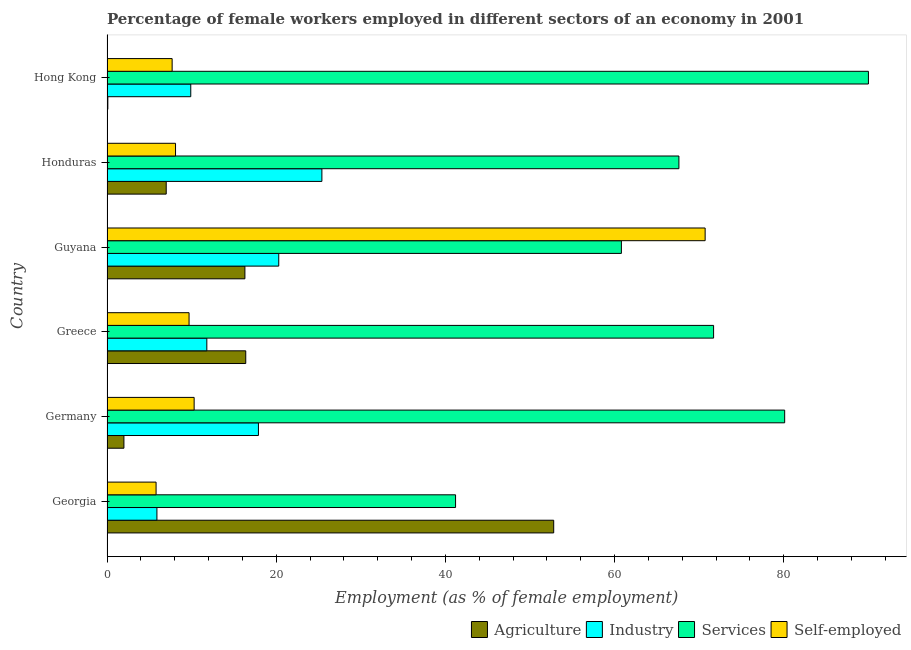How many different coloured bars are there?
Provide a succinct answer. 4. How many groups of bars are there?
Your answer should be very brief. 6. Are the number of bars on each tick of the Y-axis equal?
Keep it short and to the point. Yes. How many bars are there on the 5th tick from the bottom?
Make the answer very short. 4. What is the label of the 3rd group of bars from the top?
Your answer should be compact. Guyana. What is the percentage of female workers in services in Georgia?
Provide a short and direct response. 41.2. Across all countries, what is the maximum percentage of female workers in services?
Make the answer very short. 90. Across all countries, what is the minimum percentage of female workers in agriculture?
Your answer should be very brief. 0.1. In which country was the percentage of female workers in industry maximum?
Keep it short and to the point. Honduras. In which country was the percentage of female workers in industry minimum?
Offer a terse response. Georgia. What is the total percentage of female workers in services in the graph?
Ensure brevity in your answer.  411.4. What is the difference between the percentage of female workers in agriculture in Honduras and the percentage of female workers in services in Georgia?
Ensure brevity in your answer.  -34.2. What is the average percentage of female workers in services per country?
Ensure brevity in your answer.  68.57. In how many countries, is the percentage of self employed female workers greater than 44 %?
Make the answer very short. 1. What is the ratio of the percentage of female workers in industry in Georgia to that in Greece?
Offer a terse response. 0.5. Is the percentage of female workers in industry in Georgia less than that in Germany?
Offer a terse response. Yes. Is the difference between the percentage of female workers in services in Greece and Guyana greater than the difference between the percentage of female workers in industry in Greece and Guyana?
Give a very brief answer. Yes. What is the difference between the highest and the second highest percentage of female workers in agriculture?
Keep it short and to the point. 36.4. What is the difference between the highest and the lowest percentage of female workers in services?
Keep it short and to the point. 48.8. What does the 4th bar from the top in Germany represents?
Offer a very short reply. Agriculture. What does the 1st bar from the bottom in Guyana represents?
Give a very brief answer. Agriculture. Is it the case that in every country, the sum of the percentage of female workers in agriculture and percentage of female workers in industry is greater than the percentage of female workers in services?
Offer a very short reply. No. How many bars are there?
Keep it short and to the point. 24. What is the difference between two consecutive major ticks on the X-axis?
Give a very brief answer. 20. Does the graph contain grids?
Your response must be concise. No. Where does the legend appear in the graph?
Your response must be concise. Bottom right. How many legend labels are there?
Ensure brevity in your answer.  4. What is the title of the graph?
Offer a terse response. Percentage of female workers employed in different sectors of an economy in 2001. Does "Payroll services" appear as one of the legend labels in the graph?
Keep it short and to the point. No. What is the label or title of the X-axis?
Make the answer very short. Employment (as % of female employment). What is the Employment (as % of female employment) in Agriculture in Georgia?
Offer a terse response. 52.8. What is the Employment (as % of female employment) in Industry in Georgia?
Ensure brevity in your answer.  5.9. What is the Employment (as % of female employment) of Services in Georgia?
Keep it short and to the point. 41.2. What is the Employment (as % of female employment) in Self-employed in Georgia?
Provide a succinct answer. 5.8. What is the Employment (as % of female employment) of Industry in Germany?
Your answer should be very brief. 17.9. What is the Employment (as % of female employment) of Services in Germany?
Your answer should be compact. 80.1. What is the Employment (as % of female employment) of Self-employed in Germany?
Your answer should be compact. 10.3. What is the Employment (as % of female employment) in Agriculture in Greece?
Offer a very short reply. 16.4. What is the Employment (as % of female employment) in Industry in Greece?
Provide a succinct answer. 11.8. What is the Employment (as % of female employment) in Services in Greece?
Provide a succinct answer. 71.7. What is the Employment (as % of female employment) of Self-employed in Greece?
Offer a very short reply. 9.7. What is the Employment (as % of female employment) of Agriculture in Guyana?
Make the answer very short. 16.3. What is the Employment (as % of female employment) in Industry in Guyana?
Your answer should be compact. 20.3. What is the Employment (as % of female employment) of Services in Guyana?
Offer a very short reply. 60.8. What is the Employment (as % of female employment) in Self-employed in Guyana?
Your response must be concise. 70.7. What is the Employment (as % of female employment) of Industry in Honduras?
Make the answer very short. 25.4. What is the Employment (as % of female employment) of Services in Honduras?
Keep it short and to the point. 67.6. What is the Employment (as % of female employment) of Self-employed in Honduras?
Provide a short and direct response. 8.1. What is the Employment (as % of female employment) of Agriculture in Hong Kong?
Provide a succinct answer. 0.1. What is the Employment (as % of female employment) in Industry in Hong Kong?
Offer a very short reply. 9.9. What is the Employment (as % of female employment) in Services in Hong Kong?
Offer a very short reply. 90. What is the Employment (as % of female employment) of Self-employed in Hong Kong?
Keep it short and to the point. 7.7. Across all countries, what is the maximum Employment (as % of female employment) in Agriculture?
Provide a succinct answer. 52.8. Across all countries, what is the maximum Employment (as % of female employment) of Industry?
Ensure brevity in your answer.  25.4. Across all countries, what is the maximum Employment (as % of female employment) of Services?
Provide a short and direct response. 90. Across all countries, what is the maximum Employment (as % of female employment) of Self-employed?
Offer a terse response. 70.7. Across all countries, what is the minimum Employment (as % of female employment) in Agriculture?
Your response must be concise. 0.1. Across all countries, what is the minimum Employment (as % of female employment) in Industry?
Offer a terse response. 5.9. Across all countries, what is the minimum Employment (as % of female employment) of Services?
Offer a very short reply. 41.2. Across all countries, what is the minimum Employment (as % of female employment) of Self-employed?
Make the answer very short. 5.8. What is the total Employment (as % of female employment) in Agriculture in the graph?
Offer a very short reply. 94.6. What is the total Employment (as % of female employment) of Industry in the graph?
Your response must be concise. 91.2. What is the total Employment (as % of female employment) in Services in the graph?
Your answer should be compact. 411.4. What is the total Employment (as % of female employment) in Self-employed in the graph?
Keep it short and to the point. 112.3. What is the difference between the Employment (as % of female employment) of Agriculture in Georgia and that in Germany?
Your answer should be compact. 50.8. What is the difference between the Employment (as % of female employment) in Industry in Georgia and that in Germany?
Make the answer very short. -12. What is the difference between the Employment (as % of female employment) of Services in Georgia and that in Germany?
Offer a very short reply. -38.9. What is the difference between the Employment (as % of female employment) of Agriculture in Georgia and that in Greece?
Give a very brief answer. 36.4. What is the difference between the Employment (as % of female employment) in Services in Georgia and that in Greece?
Make the answer very short. -30.5. What is the difference between the Employment (as % of female employment) in Self-employed in Georgia and that in Greece?
Offer a very short reply. -3.9. What is the difference between the Employment (as % of female employment) of Agriculture in Georgia and that in Guyana?
Ensure brevity in your answer.  36.5. What is the difference between the Employment (as % of female employment) in Industry in Georgia and that in Guyana?
Make the answer very short. -14.4. What is the difference between the Employment (as % of female employment) in Services in Georgia and that in Guyana?
Your answer should be compact. -19.6. What is the difference between the Employment (as % of female employment) of Self-employed in Georgia and that in Guyana?
Your response must be concise. -64.9. What is the difference between the Employment (as % of female employment) of Agriculture in Georgia and that in Honduras?
Provide a succinct answer. 45.8. What is the difference between the Employment (as % of female employment) in Industry in Georgia and that in Honduras?
Your answer should be compact. -19.5. What is the difference between the Employment (as % of female employment) of Services in Georgia and that in Honduras?
Offer a very short reply. -26.4. What is the difference between the Employment (as % of female employment) of Agriculture in Georgia and that in Hong Kong?
Your answer should be very brief. 52.7. What is the difference between the Employment (as % of female employment) of Services in Georgia and that in Hong Kong?
Your response must be concise. -48.8. What is the difference between the Employment (as % of female employment) of Self-employed in Georgia and that in Hong Kong?
Keep it short and to the point. -1.9. What is the difference between the Employment (as % of female employment) of Agriculture in Germany and that in Greece?
Your response must be concise. -14.4. What is the difference between the Employment (as % of female employment) in Services in Germany and that in Greece?
Give a very brief answer. 8.4. What is the difference between the Employment (as % of female employment) in Self-employed in Germany and that in Greece?
Keep it short and to the point. 0.6. What is the difference between the Employment (as % of female employment) of Agriculture in Germany and that in Guyana?
Offer a very short reply. -14.3. What is the difference between the Employment (as % of female employment) of Services in Germany and that in Guyana?
Your answer should be very brief. 19.3. What is the difference between the Employment (as % of female employment) in Self-employed in Germany and that in Guyana?
Ensure brevity in your answer.  -60.4. What is the difference between the Employment (as % of female employment) of Industry in Germany and that in Honduras?
Your answer should be very brief. -7.5. What is the difference between the Employment (as % of female employment) of Services in Germany and that in Honduras?
Offer a very short reply. 12.5. What is the difference between the Employment (as % of female employment) in Agriculture in Germany and that in Hong Kong?
Make the answer very short. 1.9. What is the difference between the Employment (as % of female employment) of Industry in Germany and that in Hong Kong?
Give a very brief answer. 8. What is the difference between the Employment (as % of female employment) of Services in Germany and that in Hong Kong?
Provide a short and direct response. -9.9. What is the difference between the Employment (as % of female employment) in Self-employed in Greece and that in Guyana?
Your answer should be compact. -61. What is the difference between the Employment (as % of female employment) in Services in Greece and that in Honduras?
Your response must be concise. 4.1. What is the difference between the Employment (as % of female employment) of Self-employed in Greece and that in Honduras?
Offer a very short reply. 1.6. What is the difference between the Employment (as % of female employment) in Agriculture in Greece and that in Hong Kong?
Ensure brevity in your answer.  16.3. What is the difference between the Employment (as % of female employment) in Industry in Greece and that in Hong Kong?
Your response must be concise. 1.9. What is the difference between the Employment (as % of female employment) of Services in Greece and that in Hong Kong?
Your answer should be very brief. -18.3. What is the difference between the Employment (as % of female employment) of Self-employed in Greece and that in Hong Kong?
Ensure brevity in your answer.  2. What is the difference between the Employment (as % of female employment) in Agriculture in Guyana and that in Honduras?
Ensure brevity in your answer.  9.3. What is the difference between the Employment (as % of female employment) of Industry in Guyana and that in Honduras?
Keep it short and to the point. -5.1. What is the difference between the Employment (as % of female employment) of Services in Guyana and that in Honduras?
Provide a succinct answer. -6.8. What is the difference between the Employment (as % of female employment) in Self-employed in Guyana and that in Honduras?
Ensure brevity in your answer.  62.6. What is the difference between the Employment (as % of female employment) of Services in Guyana and that in Hong Kong?
Offer a terse response. -29.2. What is the difference between the Employment (as % of female employment) in Self-employed in Guyana and that in Hong Kong?
Keep it short and to the point. 63. What is the difference between the Employment (as % of female employment) in Services in Honduras and that in Hong Kong?
Provide a succinct answer. -22.4. What is the difference between the Employment (as % of female employment) of Agriculture in Georgia and the Employment (as % of female employment) of Industry in Germany?
Provide a short and direct response. 34.9. What is the difference between the Employment (as % of female employment) of Agriculture in Georgia and the Employment (as % of female employment) of Services in Germany?
Ensure brevity in your answer.  -27.3. What is the difference between the Employment (as % of female employment) in Agriculture in Georgia and the Employment (as % of female employment) in Self-employed in Germany?
Make the answer very short. 42.5. What is the difference between the Employment (as % of female employment) of Industry in Georgia and the Employment (as % of female employment) of Services in Germany?
Your answer should be very brief. -74.2. What is the difference between the Employment (as % of female employment) in Services in Georgia and the Employment (as % of female employment) in Self-employed in Germany?
Offer a terse response. 30.9. What is the difference between the Employment (as % of female employment) of Agriculture in Georgia and the Employment (as % of female employment) of Services in Greece?
Ensure brevity in your answer.  -18.9. What is the difference between the Employment (as % of female employment) of Agriculture in Georgia and the Employment (as % of female employment) of Self-employed in Greece?
Offer a terse response. 43.1. What is the difference between the Employment (as % of female employment) in Industry in Georgia and the Employment (as % of female employment) in Services in Greece?
Offer a terse response. -65.8. What is the difference between the Employment (as % of female employment) in Industry in Georgia and the Employment (as % of female employment) in Self-employed in Greece?
Make the answer very short. -3.8. What is the difference between the Employment (as % of female employment) of Services in Georgia and the Employment (as % of female employment) of Self-employed in Greece?
Your answer should be very brief. 31.5. What is the difference between the Employment (as % of female employment) of Agriculture in Georgia and the Employment (as % of female employment) of Industry in Guyana?
Make the answer very short. 32.5. What is the difference between the Employment (as % of female employment) in Agriculture in Georgia and the Employment (as % of female employment) in Services in Guyana?
Ensure brevity in your answer.  -8. What is the difference between the Employment (as % of female employment) of Agriculture in Georgia and the Employment (as % of female employment) of Self-employed in Guyana?
Your response must be concise. -17.9. What is the difference between the Employment (as % of female employment) of Industry in Georgia and the Employment (as % of female employment) of Services in Guyana?
Provide a short and direct response. -54.9. What is the difference between the Employment (as % of female employment) of Industry in Georgia and the Employment (as % of female employment) of Self-employed in Guyana?
Provide a succinct answer. -64.8. What is the difference between the Employment (as % of female employment) in Services in Georgia and the Employment (as % of female employment) in Self-employed in Guyana?
Offer a very short reply. -29.5. What is the difference between the Employment (as % of female employment) in Agriculture in Georgia and the Employment (as % of female employment) in Industry in Honduras?
Keep it short and to the point. 27.4. What is the difference between the Employment (as % of female employment) in Agriculture in Georgia and the Employment (as % of female employment) in Services in Honduras?
Provide a short and direct response. -14.8. What is the difference between the Employment (as % of female employment) of Agriculture in Georgia and the Employment (as % of female employment) of Self-employed in Honduras?
Make the answer very short. 44.7. What is the difference between the Employment (as % of female employment) in Industry in Georgia and the Employment (as % of female employment) in Services in Honduras?
Offer a terse response. -61.7. What is the difference between the Employment (as % of female employment) in Services in Georgia and the Employment (as % of female employment) in Self-employed in Honduras?
Offer a terse response. 33.1. What is the difference between the Employment (as % of female employment) in Agriculture in Georgia and the Employment (as % of female employment) in Industry in Hong Kong?
Keep it short and to the point. 42.9. What is the difference between the Employment (as % of female employment) in Agriculture in Georgia and the Employment (as % of female employment) in Services in Hong Kong?
Keep it short and to the point. -37.2. What is the difference between the Employment (as % of female employment) of Agriculture in Georgia and the Employment (as % of female employment) of Self-employed in Hong Kong?
Keep it short and to the point. 45.1. What is the difference between the Employment (as % of female employment) in Industry in Georgia and the Employment (as % of female employment) in Services in Hong Kong?
Offer a terse response. -84.1. What is the difference between the Employment (as % of female employment) of Services in Georgia and the Employment (as % of female employment) of Self-employed in Hong Kong?
Offer a terse response. 33.5. What is the difference between the Employment (as % of female employment) in Agriculture in Germany and the Employment (as % of female employment) in Services in Greece?
Your response must be concise. -69.7. What is the difference between the Employment (as % of female employment) in Agriculture in Germany and the Employment (as % of female employment) in Self-employed in Greece?
Make the answer very short. -7.7. What is the difference between the Employment (as % of female employment) in Industry in Germany and the Employment (as % of female employment) in Services in Greece?
Your response must be concise. -53.8. What is the difference between the Employment (as % of female employment) of Industry in Germany and the Employment (as % of female employment) of Self-employed in Greece?
Ensure brevity in your answer.  8.2. What is the difference between the Employment (as % of female employment) of Services in Germany and the Employment (as % of female employment) of Self-employed in Greece?
Provide a succinct answer. 70.4. What is the difference between the Employment (as % of female employment) in Agriculture in Germany and the Employment (as % of female employment) in Industry in Guyana?
Offer a very short reply. -18.3. What is the difference between the Employment (as % of female employment) of Agriculture in Germany and the Employment (as % of female employment) of Services in Guyana?
Ensure brevity in your answer.  -58.8. What is the difference between the Employment (as % of female employment) of Agriculture in Germany and the Employment (as % of female employment) of Self-employed in Guyana?
Keep it short and to the point. -68.7. What is the difference between the Employment (as % of female employment) in Industry in Germany and the Employment (as % of female employment) in Services in Guyana?
Ensure brevity in your answer.  -42.9. What is the difference between the Employment (as % of female employment) in Industry in Germany and the Employment (as % of female employment) in Self-employed in Guyana?
Make the answer very short. -52.8. What is the difference between the Employment (as % of female employment) in Services in Germany and the Employment (as % of female employment) in Self-employed in Guyana?
Make the answer very short. 9.4. What is the difference between the Employment (as % of female employment) of Agriculture in Germany and the Employment (as % of female employment) of Industry in Honduras?
Your response must be concise. -23.4. What is the difference between the Employment (as % of female employment) in Agriculture in Germany and the Employment (as % of female employment) in Services in Honduras?
Make the answer very short. -65.6. What is the difference between the Employment (as % of female employment) of Industry in Germany and the Employment (as % of female employment) of Services in Honduras?
Offer a very short reply. -49.7. What is the difference between the Employment (as % of female employment) of Industry in Germany and the Employment (as % of female employment) of Self-employed in Honduras?
Your answer should be very brief. 9.8. What is the difference between the Employment (as % of female employment) in Services in Germany and the Employment (as % of female employment) in Self-employed in Honduras?
Your answer should be compact. 72. What is the difference between the Employment (as % of female employment) of Agriculture in Germany and the Employment (as % of female employment) of Industry in Hong Kong?
Offer a terse response. -7.9. What is the difference between the Employment (as % of female employment) of Agriculture in Germany and the Employment (as % of female employment) of Services in Hong Kong?
Give a very brief answer. -88. What is the difference between the Employment (as % of female employment) of Agriculture in Germany and the Employment (as % of female employment) of Self-employed in Hong Kong?
Your answer should be compact. -5.7. What is the difference between the Employment (as % of female employment) in Industry in Germany and the Employment (as % of female employment) in Services in Hong Kong?
Offer a very short reply. -72.1. What is the difference between the Employment (as % of female employment) in Industry in Germany and the Employment (as % of female employment) in Self-employed in Hong Kong?
Keep it short and to the point. 10.2. What is the difference between the Employment (as % of female employment) in Services in Germany and the Employment (as % of female employment) in Self-employed in Hong Kong?
Provide a short and direct response. 72.4. What is the difference between the Employment (as % of female employment) in Agriculture in Greece and the Employment (as % of female employment) in Services in Guyana?
Your answer should be very brief. -44.4. What is the difference between the Employment (as % of female employment) of Agriculture in Greece and the Employment (as % of female employment) of Self-employed in Guyana?
Your answer should be very brief. -54.3. What is the difference between the Employment (as % of female employment) in Industry in Greece and the Employment (as % of female employment) in Services in Guyana?
Offer a terse response. -49. What is the difference between the Employment (as % of female employment) in Industry in Greece and the Employment (as % of female employment) in Self-employed in Guyana?
Make the answer very short. -58.9. What is the difference between the Employment (as % of female employment) in Agriculture in Greece and the Employment (as % of female employment) in Services in Honduras?
Offer a terse response. -51.2. What is the difference between the Employment (as % of female employment) in Agriculture in Greece and the Employment (as % of female employment) in Self-employed in Honduras?
Offer a very short reply. 8.3. What is the difference between the Employment (as % of female employment) in Industry in Greece and the Employment (as % of female employment) in Services in Honduras?
Your answer should be compact. -55.8. What is the difference between the Employment (as % of female employment) in Services in Greece and the Employment (as % of female employment) in Self-employed in Honduras?
Your answer should be compact. 63.6. What is the difference between the Employment (as % of female employment) in Agriculture in Greece and the Employment (as % of female employment) in Services in Hong Kong?
Keep it short and to the point. -73.6. What is the difference between the Employment (as % of female employment) of Industry in Greece and the Employment (as % of female employment) of Services in Hong Kong?
Offer a terse response. -78.2. What is the difference between the Employment (as % of female employment) in Agriculture in Guyana and the Employment (as % of female employment) in Services in Honduras?
Provide a succinct answer. -51.3. What is the difference between the Employment (as % of female employment) in Industry in Guyana and the Employment (as % of female employment) in Services in Honduras?
Give a very brief answer. -47.3. What is the difference between the Employment (as % of female employment) of Services in Guyana and the Employment (as % of female employment) of Self-employed in Honduras?
Make the answer very short. 52.7. What is the difference between the Employment (as % of female employment) in Agriculture in Guyana and the Employment (as % of female employment) in Services in Hong Kong?
Provide a succinct answer. -73.7. What is the difference between the Employment (as % of female employment) in Agriculture in Guyana and the Employment (as % of female employment) in Self-employed in Hong Kong?
Provide a succinct answer. 8.6. What is the difference between the Employment (as % of female employment) of Industry in Guyana and the Employment (as % of female employment) of Services in Hong Kong?
Make the answer very short. -69.7. What is the difference between the Employment (as % of female employment) of Services in Guyana and the Employment (as % of female employment) of Self-employed in Hong Kong?
Provide a short and direct response. 53.1. What is the difference between the Employment (as % of female employment) in Agriculture in Honduras and the Employment (as % of female employment) in Industry in Hong Kong?
Provide a short and direct response. -2.9. What is the difference between the Employment (as % of female employment) in Agriculture in Honduras and the Employment (as % of female employment) in Services in Hong Kong?
Make the answer very short. -83. What is the difference between the Employment (as % of female employment) of Agriculture in Honduras and the Employment (as % of female employment) of Self-employed in Hong Kong?
Your answer should be compact. -0.7. What is the difference between the Employment (as % of female employment) of Industry in Honduras and the Employment (as % of female employment) of Services in Hong Kong?
Offer a terse response. -64.6. What is the difference between the Employment (as % of female employment) in Industry in Honduras and the Employment (as % of female employment) in Self-employed in Hong Kong?
Offer a very short reply. 17.7. What is the difference between the Employment (as % of female employment) of Services in Honduras and the Employment (as % of female employment) of Self-employed in Hong Kong?
Offer a very short reply. 59.9. What is the average Employment (as % of female employment) in Agriculture per country?
Ensure brevity in your answer.  15.77. What is the average Employment (as % of female employment) of Services per country?
Provide a succinct answer. 68.57. What is the average Employment (as % of female employment) of Self-employed per country?
Provide a succinct answer. 18.72. What is the difference between the Employment (as % of female employment) in Agriculture and Employment (as % of female employment) in Industry in Georgia?
Keep it short and to the point. 46.9. What is the difference between the Employment (as % of female employment) in Industry and Employment (as % of female employment) in Services in Georgia?
Provide a succinct answer. -35.3. What is the difference between the Employment (as % of female employment) in Services and Employment (as % of female employment) in Self-employed in Georgia?
Keep it short and to the point. 35.4. What is the difference between the Employment (as % of female employment) in Agriculture and Employment (as % of female employment) in Industry in Germany?
Offer a very short reply. -15.9. What is the difference between the Employment (as % of female employment) of Agriculture and Employment (as % of female employment) of Services in Germany?
Ensure brevity in your answer.  -78.1. What is the difference between the Employment (as % of female employment) in Industry and Employment (as % of female employment) in Services in Germany?
Provide a short and direct response. -62.2. What is the difference between the Employment (as % of female employment) in Industry and Employment (as % of female employment) in Self-employed in Germany?
Your response must be concise. 7.6. What is the difference between the Employment (as % of female employment) in Services and Employment (as % of female employment) in Self-employed in Germany?
Provide a short and direct response. 69.8. What is the difference between the Employment (as % of female employment) in Agriculture and Employment (as % of female employment) in Industry in Greece?
Keep it short and to the point. 4.6. What is the difference between the Employment (as % of female employment) in Agriculture and Employment (as % of female employment) in Services in Greece?
Give a very brief answer. -55.3. What is the difference between the Employment (as % of female employment) of Agriculture and Employment (as % of female employment) of Self-employed in Greece?
Offer a very short reply. 6.7. What is the difference between the Employment (as % of female employment) of Industry and Employment (as % of female employment) of Services in Greece?
Ensure brevity in your answer.  -59.9. What is the difference between the Employment (as % of female employment) of Services and Employment (as % of female employment) of Self-employed in Greece?
Your response must be concise. 62. What is the difference between the Employment (as % of female employment) of Agriculture and Employment (as % of female employment) of Services in Guyana?
Give a very brief answer. -44.5. What is the difference between the Employment (as % of female employment) in Agriculture and Employment (as % of female employment) in Self-employed in Guyana?
Offer a very short reply. -54.4. What is the difference between the Employment (as % of female employment) in Industry and Employment (as % of female employment) in Services in Guyana?
Ensure brevity in your answer.  -40.5. What is the difference between the Employment (as % of female employment) of Industry and Employment (as % of female employment) of Self-employed in Guyana?
Offer a terse response. -50.4. What is the difference between the Employment (as % of female employment) in Services and Employment (as % of female employment) in Self-employed in Guyana?
Your answer should be compact. -9.9. What is the difference between the Employment (as % of female employment) of Agriculture and Employment (as % of female employment) of Industry in Honduras?
Offer a very short reply. -18.4. What is the difference between the Employment (as % of female employment) of Agriculture and Employment (as % of female employment) of Services in Honduras?
Keep it short and to the point. -60.6. What is the difference between the Employment (as % of female employment) of Agriculture and Employment (as % of female employment) of Self-employed in Honduras?
Your answer should be compact. -1.1. What is the difference between the Employment (as % of female employment) of Industry and Employment (as % of female employment) of Services in Honduras?
Offer a very short reply. -42.2. What is the difference between the Employment (as % of female employment) of Services and Employment (as % of female employment) of Self-employed in Honduras?
Your answer should be compact. 59.5. What is the difference between the Employment (as % of female employment) in Agriculture and Employment (as % of female employment) in Industry in Hong Kong?
Keep it short and to the point. -9.8. What is the difference between the Employment (as % of female employment) in Agriculture and Employment (as % of female employment) in Services in Hong Kong?
Provide a succinct answer. -89.9. What is the difference between the Employment (as % of female employment) in Agriculture and Employment (as % of female employment) in Self-employed in Hong Kong?
Keep it short and to the point. -7.6. What is the difference between the Employment (as % of female employment) of Industry and Employment (as % of female employment) of Services in Hong Kong?
Provide a succinct answer. -80.1. What is the difference between the Employment (as % of female employment) in Industry and Employment (as % of female employment) in Self-employed in Hong Kong?
Offer a very short reply. 2.2. What is the difference between the Employment (as % of female employment) of Services and Employment (as % of female employment) of Self-employed in Hong Kong?
Keep it short and to the point. 82.3. What is the ratio of the Employment (as % of female employment) in Agriculture in Georgia to that in Germany?
Your answer should be compact. 26.4. What is the ratio of the Employment (as % of female employment) in Industry in Georgia to that in Germany?
Your response must be concise. 0.33. What is the ratio of the Employment (as % of female employment) of Services in Georgia to that in Germany?
Provide a succinct answer. 0.51. What is the ratio of the Employment (as % of female employment) in Self-employed in Georgia to that in Germany?
Provide a short and direct response. 0.56. What is the ratio of the Employment (as % of female employment) in Agriculture in Georgia to that in Greece?
Keep it short and to the point. 3.22. What is the ratio of the Employment (as % of female employment) in Industry in Georgia to that in Greece?
Offer a very short reply. 0.5. What is the ratio of the Employment (as % of female employment) in Services in Georgia to that in Greece?
Offer a very short reply. 0.57. What is the ratio of the Employment (as % of female employment) in Self-employed in Georgia to that in Greece?
Your answer should be very brief. 0.6. What is the ratio of the Employment (as % of female employment) of Agriculture in Georgia to that in Guyana?
Keep it short and to the point. 3.24. What is the ratio of the Employment (as % of female employment) in Industry in Georgia to that in Guyana?
Your answer should be very brief. 0.29. What is the ratio of the Employment (as % of female employment) in Services in Georgia to that in Guyana?
Your answer should be very brief. 0.68. What is the ratio of the Employment (as % of female employment) in Self-employed in Georgia to that in Guyana?
Offer a terse response. 0.08. What is the ratio of the Employment (as % of female employment) in Agriculture in Georgia to that in Honduras?
Your answer should be very brief. 7.54. What is the ratio of the Employment (as % of female employment) of Industry in Georgia to that in Honduras?
Provide a short and direct response. 0.23. What is the ratio of the Employment (as % of female employment) of Services in Georgia to that in Honduras?
Offer a very short reply. 0.61. What is the ratio of the Employment (as % of female employment) in Self-employed in Georgia to that in Honduras?
Offer a very short reply. 0.72. What is the ratio of the Employment (as % of female employment) in Agriculture in Georgia to that in Hong Kong?
Offer a terse response. 528. What is the ratio of the Employment (as % of female employment) of Industry in Georgia to that in Hong Kong?
Your answer should be very brief. 0.6. What is the ratio of the Employment (as % of female employment) of Services in Georgia to that in Hong Kong?
Your answer should be very brief. 0.46. What is the ratio of the Employment (as % of female employment) of Self-employed in Georgia to that in Hong Kong?
Your response must be concise. 0.75. What is the ratio of the Employment (as % of female employment) in Agriculture in Germany to that in Greece?
Give a very brief answer. 0.12. What is the ratio of the Employment (as % of female employment) of Industry in Germany to that in Greece?
Your answer should be compact. 1.52. What is the ratio of the Employment (as % of female employment) in Services in Germany to that in Greece?
Offer a very short reply. 1.12. What is the ratio of the Employment (as % of female employment) of Self-employed in Germany to that in Greece?
Offer a terse response. 1.06. What is the ratio of the Employment (as % of female employment) in Agriculture in Germany to that in Guyana?
Your answer should be very brief. 0.12. What is the ratio of the Employment (as % of female employment) in Industry in Germany to that in Guyana?
Your answer should be very brief. 0.88. What is the ratio of the Employment (as % of female employment) of Services in Germany to that in Guyana?
Your response must be concise. 1.32. What is the ratio of the Employment (as % of female employment) in Self-employed in Germany to that in Guyana?
Ensure brevity in your answer.  0.15. What is the ratio of the Employment (as % of female employment) of Agriculture in Germany to that in Honduras?
Offer a very short reply. 0.29. What is the ratio of the Employment (as % of female employment) in Industry in Germany to that in Honduras?
Your answer should be very brief. 0.7. What is the ratio of the Employment (as % of female employment) of Services in Germany to that in Honduras?
Provide a succinct answer. 1.18. What is the ratio of the Employment (as % of female employment) in Self-employed in Germany to that in Honduras?
Make the answer very short. 1.27. What is the ratio of the Employment (as % of female employment) in Agriculture in Germany to that in Hong Kong?
Your answer should be very brief. 20. What is the ratio of the Employment (as % of female employment) in Industry in Germany to that in Hong Kong?
Your response must be concise. 1.81. What is the ratio of the Employment (as % of female employment) of Services in Germany to that in Hong Kong?
Give a very brief answer. 0.89. What is the ratio of the Employment (as % of female employment) in Self-employed in Germany to that in Hong Kong?
Provide a succinct answer. 1.34. What is the ratio of the Employment (as % of female employment) of Industry in Greece to that in Guyana?
Keep it short and to the point. 0.58. What is the ratio of the Employment (as % of female employment) of Services in Greece to that in Guyana?
Make the answer very short. 1.18. What is the ratio of the Employment (as % of female employment) in Self-employed in Greece to that in Guyana?
Provide a short and direct response. 0.14. What is the ratio of the Employment (as % of female employment) in Agriculture in Greece to that in Honduras?
Your answer should be very brief. 2.34. What is the ratio of the Employment (as % of female employment) of Industry in Greece to that in Honduras?
Keep it short and to the point. 0.46. What is the ratio of the Employment (as % of female employment) of Services in Greece to that in Honduras?
Keep it short and to the point. 1.06. What is the ratio of the Employment (as % of female employment) of Self-employed in Greece to that in Honduras?
Keep it short and to the point. 1.2. What is the ratio of the Employment (as % of female employment) in Agriculture in Greece to that in Hong Kong?
Your response must be concise. 164. What is the ratio of the Employment (as % of female employment) of Industry in Greece to that in Hong Kong?
Your answer should be compact. 1.19. What is the ratio of the Employment (as % of female employment) in Services in Greece to that in Hong Kong?
Make the answer very short. 0.8. What is the ratio of the Employment (as % of female employment) of Self-employed in Greece to that in Hong Kong?
Provide a short and direct response. 1.26. What is the ratio of the Employment (as % of female employment) in Agriculture in Guyana to that in Honduras?
Ensure brevity in your answer.  2.33. What is the ratio of the Employment (as % of female employment) in Industry in Guyana to that in Honduras?
Keep it short and to the point. 0.8. What is the ratio of the Employment (as % of female employment) of Services in Guyana to that in Honduras?
Your answer should be very brief. 0.9. What is the ratio of the Employment (as % of female employment) of Self-employed in Guyana to that in Honduras?
Keep it short and to the point. 8.73. What is the ratio of the Employment (as % of female employment) of Agriculture in Guyana to that in Hong Kong?
Offer a terse response. 163. What is the ratio of the Employment (as % of female employment) in Industry in Guyana to that in Hong Kong?
Make the answer very short. 2.05. What is the ratio of the Employment (as % of female employment) in Services in Guyana to that in Hong Kong?
Offer a very short reply. 0.68. What is the ratio of the Employment (as % of female employment) of Self-employed in Guyana to that in Hong Kong?
Give a very brief answer. 9.18. What is the ratio of the Employment (as % of female employment) in Industry in Honduras to that in Hong Kong?
Provide a short and direct response. 2.57. What is the ratio of the Employment (as % of female employment) in Services in Honduras to that in Hong Kong?
Give a very brief answer. 0.75. What is the ratio of the Employment (as % of female employment) in Self-employed in Honduras to that in Hong Kong?
Your answer should be compact. 1.05. What is the difference between the highest and the second highest Employment (as % of female employment) in Agriculture?
Offer a very short reply. 36.4. What is the difference between the highest and the second highest Employment (as % of female employment) in Industry?
Your answer should be very brief. 5.1. What is the difference between the highest and the second highest Employment (as % of female employment) of Services?
Keep it short and to the point. 9.9. What is the difference between the highest and the second highest Employment (as % of female employment) in Self-employed?
Provide a succinct answer. 60.4. What is the difference between the highest and the lowest Employment (as % of female employment) of Agriculture?
Offer a very short reply. 52.7. What is the difference between the highest and the lowest Employment (as % of female employment) of Industry?
Provide a short and direct response. 19.5. What is the difference between the highest and the lowest Employment (as % of female employment) in Services?
Your response must be concise. 48.8. What is the difference between the highest and the lowest Employment (as % of female employment) of Self-employed?
Make the answer very short. 64.9. 